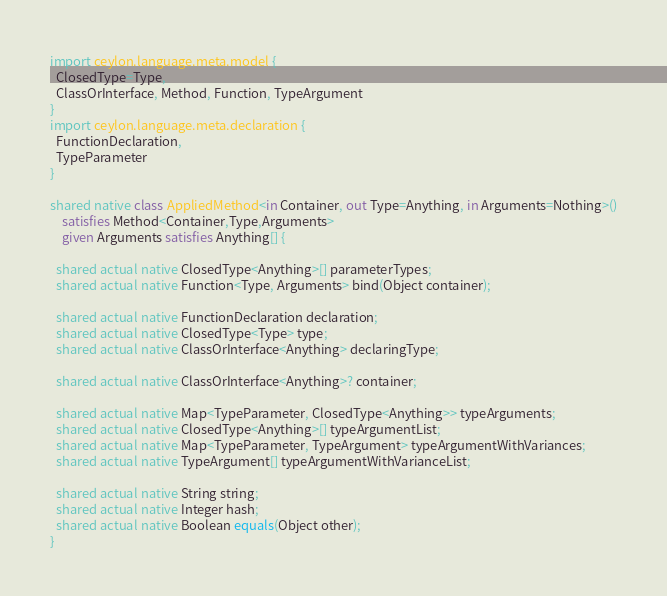Convert code to text. <code><loc_0><loc_0><loc_500><loc_500><_Ceylon_>import ceylon.language.meta.model {
  ClosedType=Type,
  ClassOrInterface, Method, Function, TypeArgument
}
import ceylon.language.meta.declaration {
  FunctionDeclaration,
  TypeParameter
}

shared native class AppliedMethod<in Container, out Type=Anything, in Arguments=Nothing>()
    satisfies Method<Container,Type,Arguments>
    given Arguments satisfies Anything[] {

  shared actual native ClosedType<Anything>[] parameterTypes;
  shared actual native Function<Type, Arguments> bind(Object container);

  shared actual native FunctionDeclaration declaration;
  shared actual native ClosedType<Type> type;
  shared actual native ClassOrInterface<Anything> declaringType;

  shared actual native ClassOrInterface<Anything>? container;

  shared actual native Map<TypeParameter, ClosedType<Anything>> typeArguments;
  shared actual native ClosedType<Anything>[] typeArgumentList;
  shared actual native Map<TypeParameter, TypeArgument> typeArgumentWithVariances;
  shared actual native TypeArgument[] typeArgumentWithVarianceList;

  shared actual native String string;
  shared actual native Integer hash;
  shared actual native Boolean equals(Object other);
}
</code> 